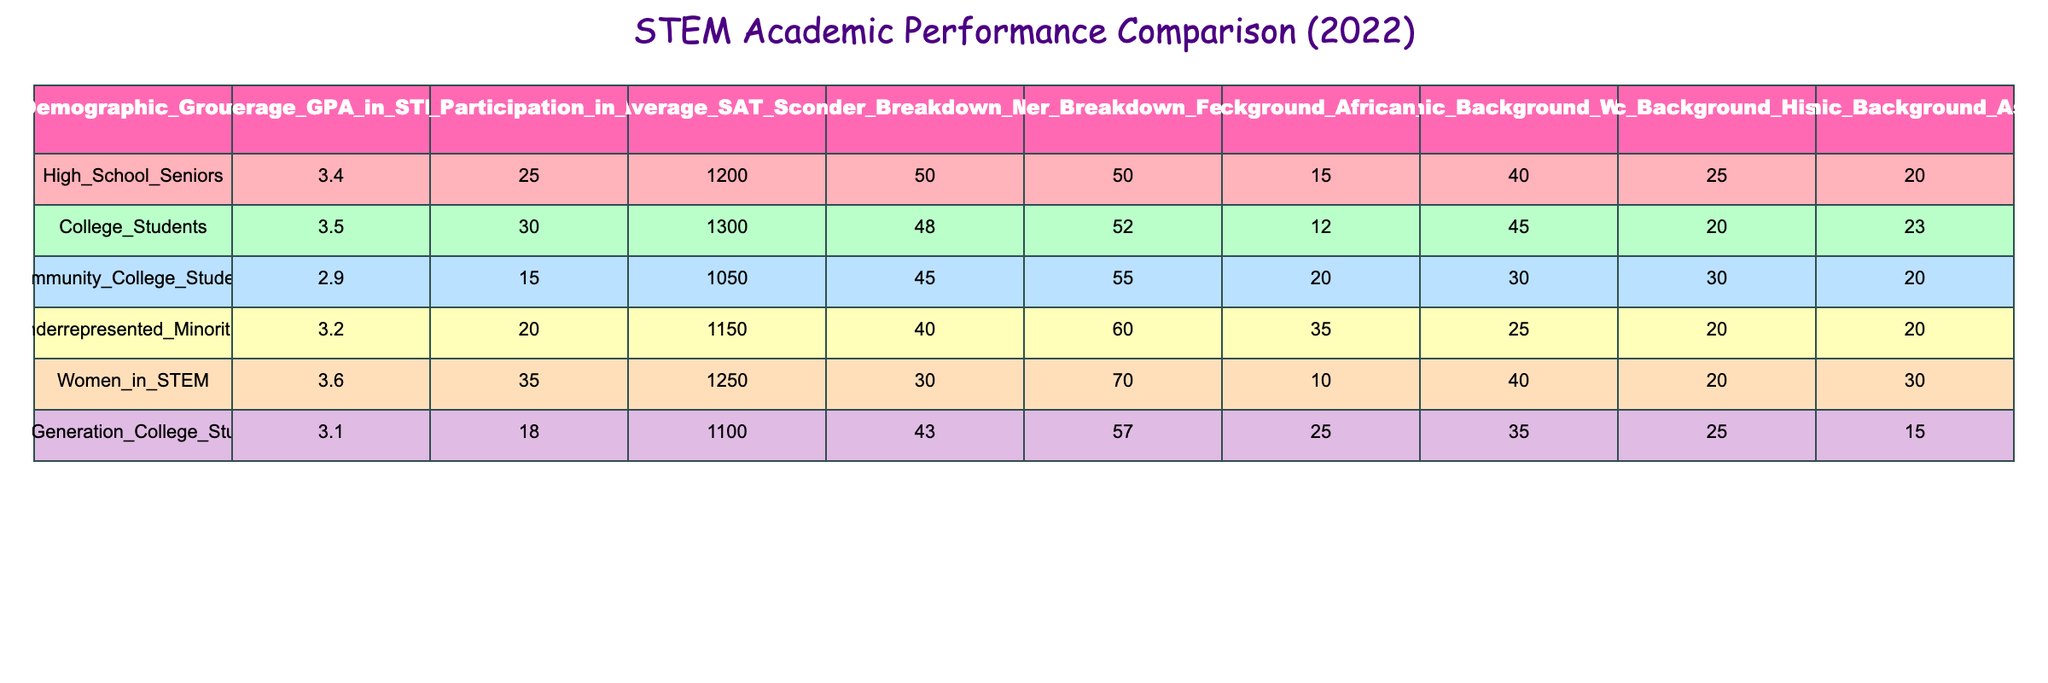What is the average GPA for Women in STEM? In the table, the Average_GPA_in_STEM for Women in STEM is listed directly as 3.6.
Answer: 3.6 Which demographic group has the highest average SAT score? By examining the Average_SAT_Score column, College Students have the highest average SAT score at 1300.
Answer: College Students What is the percentage difference in participation in AP courses between High School Seniors and First Generation College Students? The Percentage_Participation_in_AP_Courses for High School Seniors is 25% and for First Generation College Students is 18%. The difference is 25% - 18% = 7%.
Answer: 7% Is the average GPA for Community College Students greater than that of Underrepresented Minorities? The Average_GPA_in_STEM for Community College Students is 2.9, while for Underrepresented Minorities it is 3.2. Since 2.9 is less than 3.2, the statement is false.
Answer: No What demographic has the lowest average GPA, and what is that GPA? Looking at the Average_GPA_in_STEM column, Community College Students have the lowest GPA at 2.9.
Answer: Community College Students, 2.9 Calculate the average percentage participation in AP courses for all groups combined. The percentages are 25, 30, 15, 20, 35, and 18. The total is 25 + 30 + 15 + 20 + 35 + 18 = 143. There are 6 groups, so the average is 143 / 6 = 23.83 (rounded to two decimal places).
Answer: 23.83 How many more females participate in AP courses compared to males in the Women in STEM demographic? For Women in STEM, the Gender_Breakdown shows 70% for females and 30% for males. The difference is 70% - 30% = 40%.
Answer: 40% Are all demographic groups showing a percentage participation in AP courses above 15%? The table lists the participation percentages as 25, 30, 15, 20, 35, and 18. Since Community College Students only have 15%, the statement is false.
Answer: No 